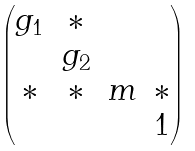Convert formula to latex. <formula><loc_0><loc_0><loc_500><loc_500>\begin{pmatrix} g _ { 1 } & * & & \\ & g _ { 2 } & & \\ * & * & m & * \\ & & & 1 \end{pmatrix}</formula> 